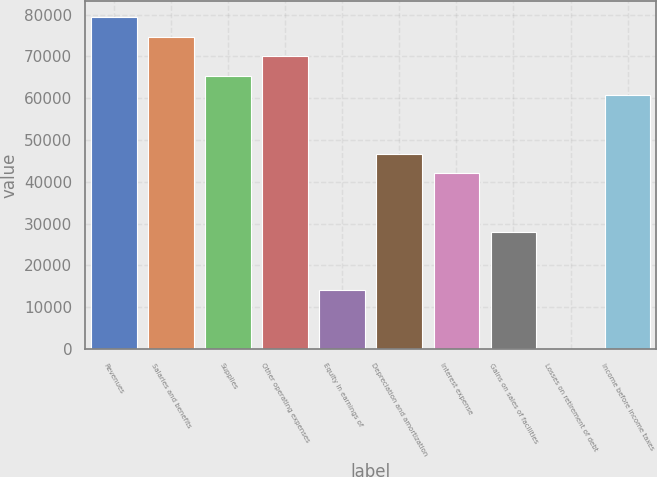Convert chart. <chart><loc_0><loc_0><loc_500><loc_500><bar_chart><fcel>Revenues<fcel>Salaries and benefits<fcel>Supplies<fcel>Other operating expenses<fcel>Equity in earnings of<fcel>Depreciation and amortization<fcel>Interest expense<fcel>Gains on sales of facilities<fcel>Losses on retirement of debt<fcel>Income before income taxes<nl><fcel>79344.6<fcel>74677.8<fcel>65344.2<fcel>70011<fcel>14009.4<fcel>46677<fcel>42010.2<fcel>28009.8<fcel>9<fcel>60677.4<nl></chart> 